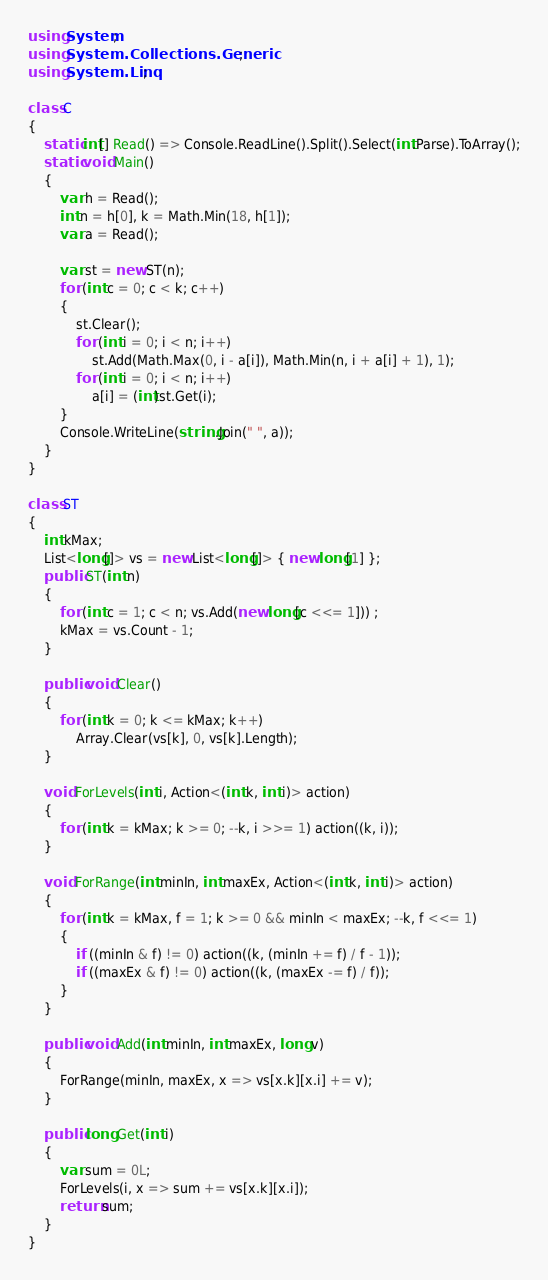Convert code to text. <code><loc_0><loc_0><loc_500><loc_500><_C#_>using System;
using System.Collections.Generic;
using System.Linq;

class C
{
	static int[] Read() => Console.ReadLine().Split().Select(int.Parse).ToArray();
	static void Main()
	{
		var h = Read();
		int n = h[0], k = Math.Min(18, h[1]);
		var a = Read();

		var st = new ST(n);
		for (int c = 0; c < k; c++)
		{
			st.Clear();
			for (int i = 0; i < n; i++)
				st.Add(Math.Max(0, i - a[i]), Math.Min(n, i + a[i] + 1), 1);
			for (int i = 0; i < n; i++)
				a[i] = (int)st.Get(i);
		}
		Console.WriteLine(string.Join(" ", a));
	}
}

class ST
{
	int kMax;
	List<long[]> vs = new List<long[]> { new long[1] };
	public ST(int n)
	{
		for (int c = 1; c < n; vs.Add(new long[c <<= 1])) ;
		kMax = vs.Count - 1;
	}

	public void Clear()
	{
		for (int k = 0; k <= kMax; k++)
			Array.Clear(vs[k], 0, vs[k].Length);
	}

	void ForLevels(int i, Action<(int k, int i)> action)
	{
		for (int k = kMax; k >= 0; --k, i >>= 1) action((k, i));
	}

	void ForRange(int minIn, int maxEx, Action<(int k, int i)> action)
	{
		for (int k = kMax, f = 1; k >= 0 && minIn < maxEx; --k, f <<= 1)
		{
			if ((minIn & f) != 0) action((k, (minIn += f) / f - 1));
			if ((maxEx & f) != 0) action((k, (maxEx -= f) / f));
		}
	}

	public void Add(int minIn, int maxEx, long v)
	{
		ForRange(minIn, maxEx, x => vs[x.k][x.i] += v);
	}

	public long Get(int i)
	{
		var sum = 0L;
		ForLevels(i, x => sum += vs[x.k][x.i]);
		return sum;
	}
}
</code> 